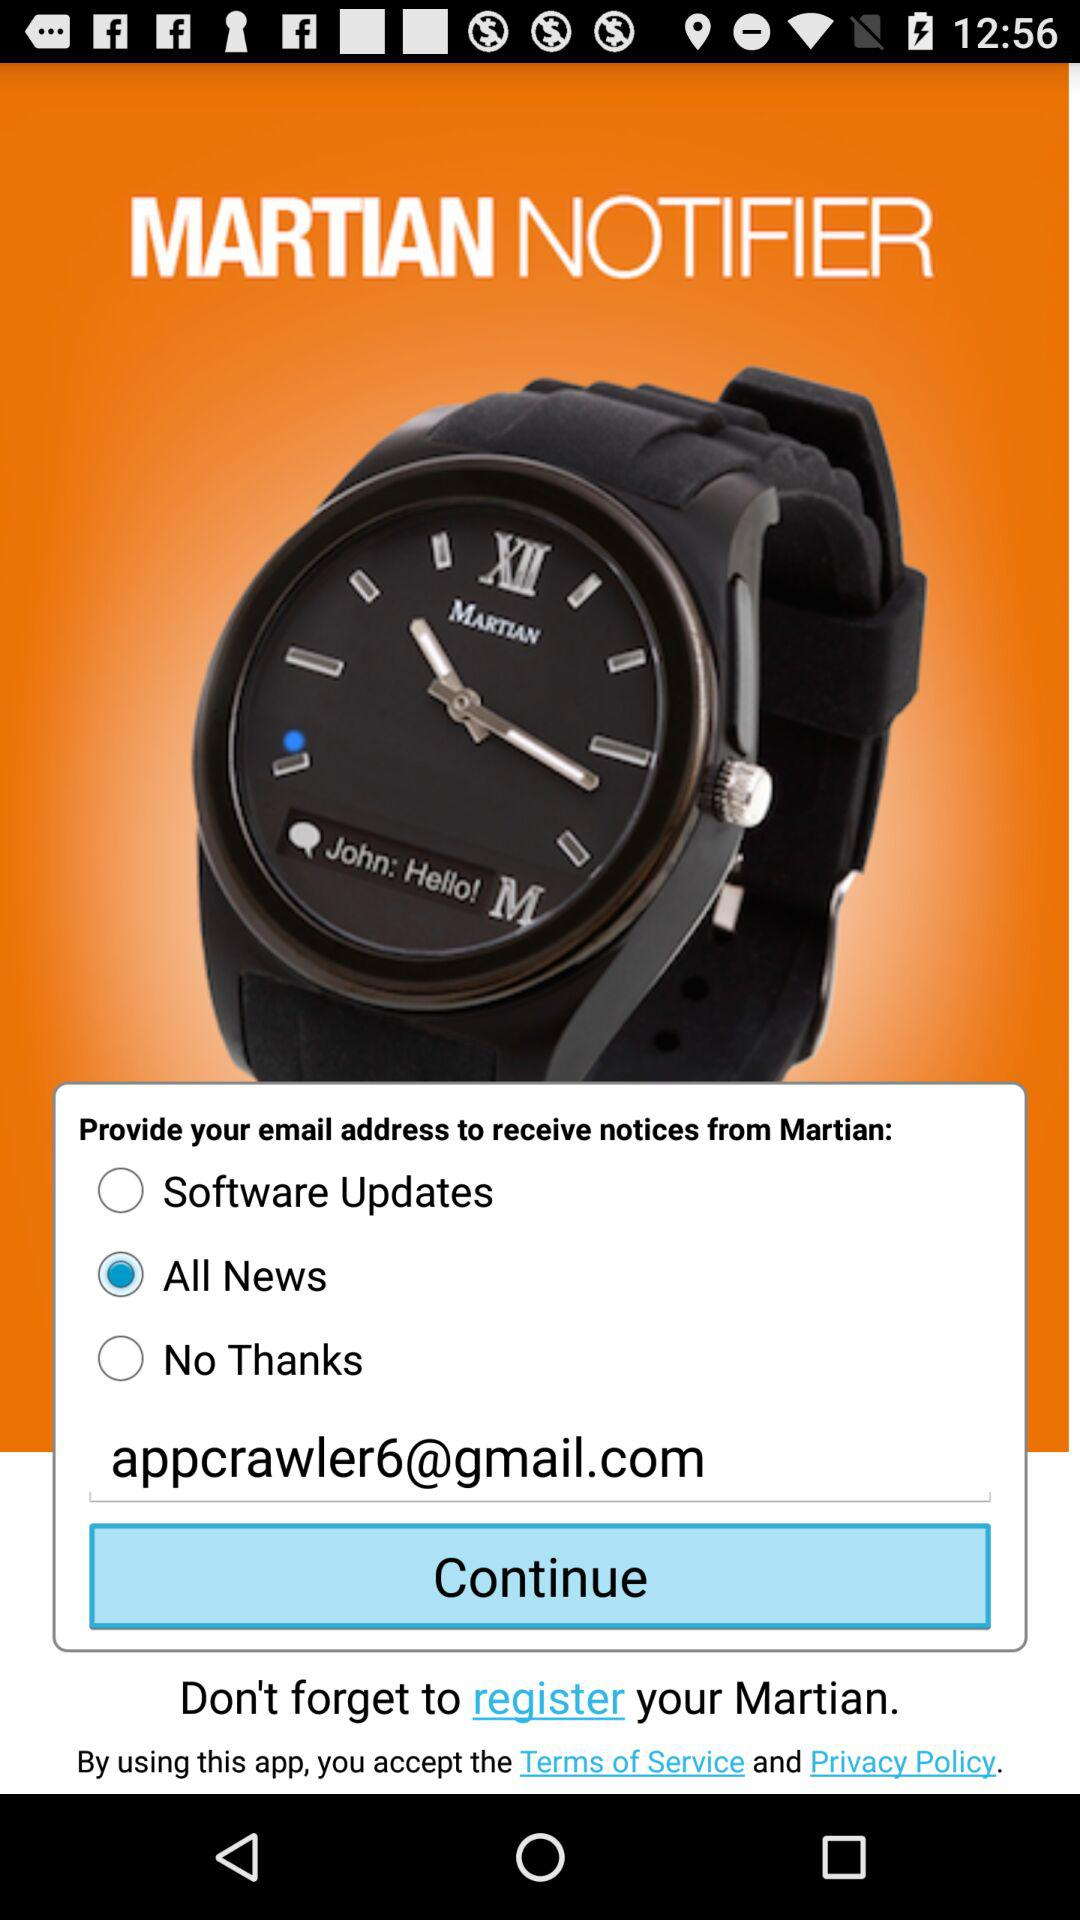What is the brand name of the watch? The brand name is "MARTIAN NOTIFIER". 